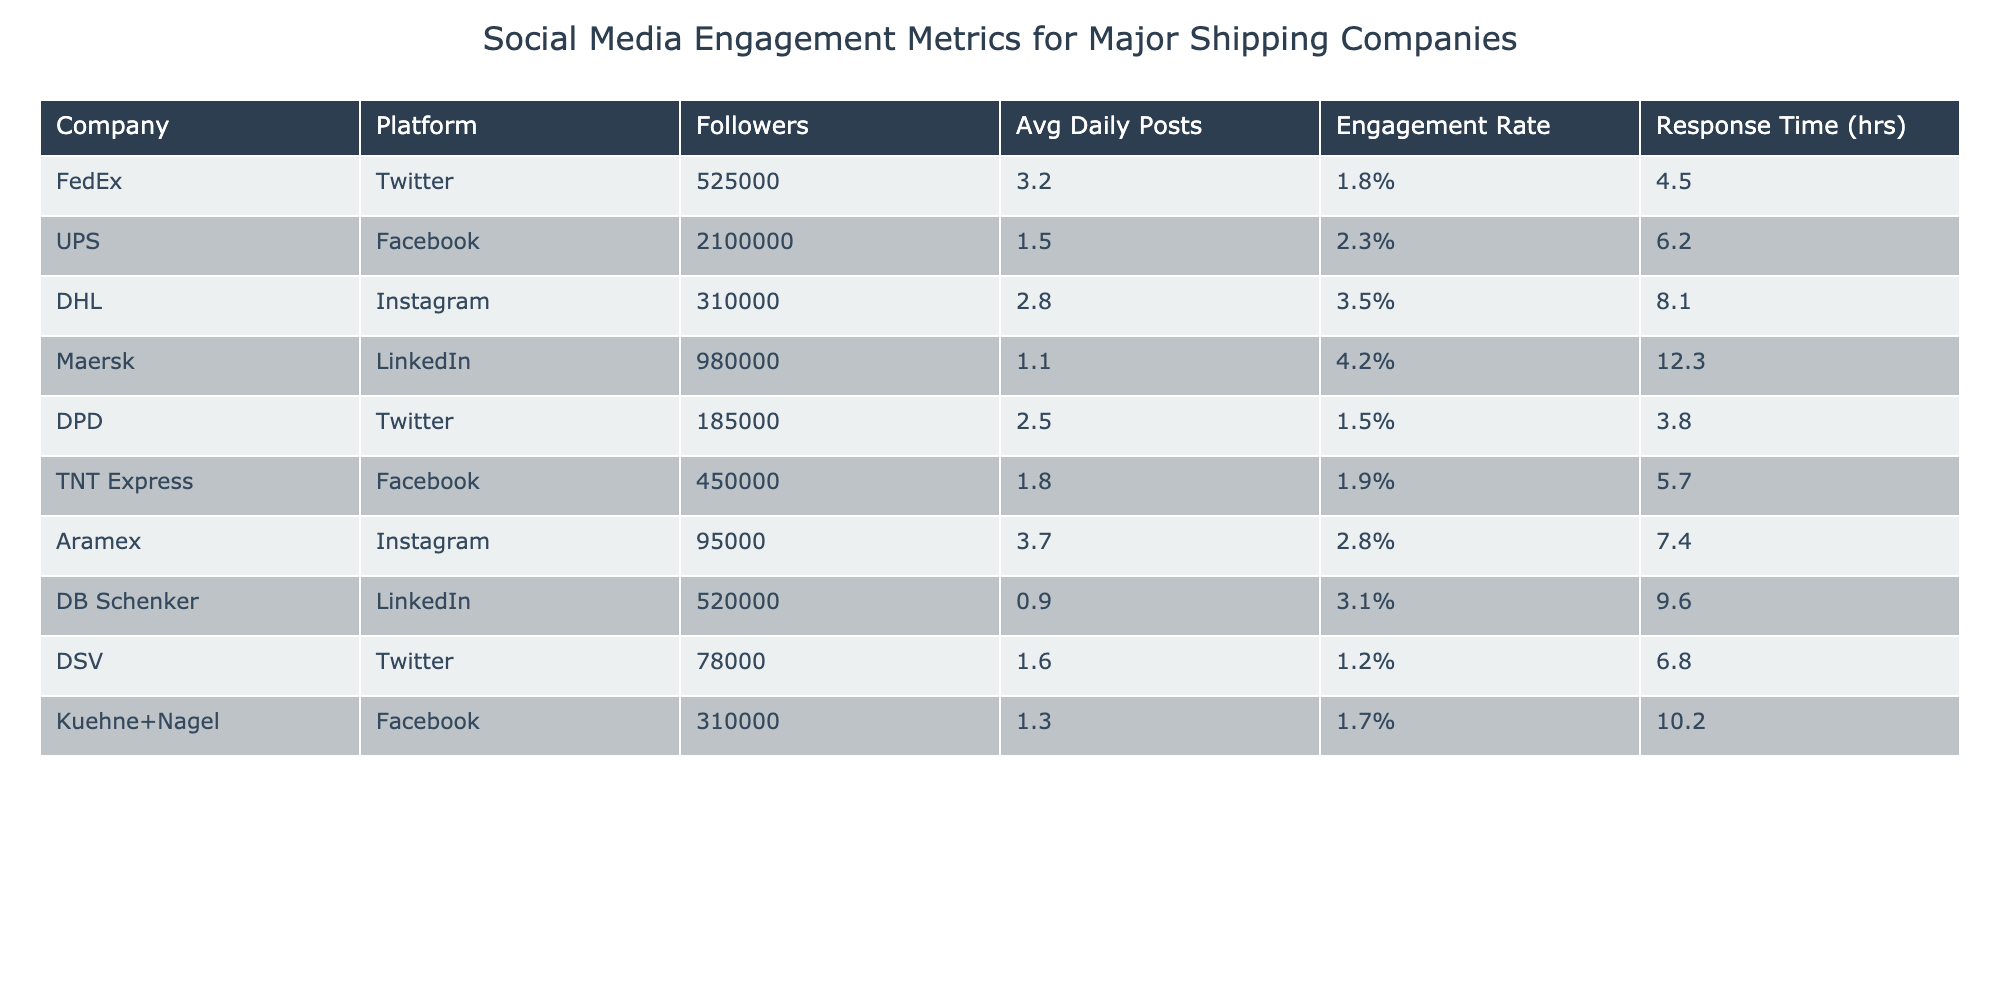What company has the highest number of followers on social media? By reviewing the 'Followers' column, UPS has the highest number of followers with 2,100,000.
Answer: UPS Which social media platform has the highest average daily posts? Looking at the 'Avg Daily Posts' column, Aramex on Instagram has the highest at 3.7 posts per day.
Answer: Aramex on Instagram What is the engagement rate for DHL? The engagement rate for DHL is listed in the 'Engagement Rate' column as 3.5%.
Answer: 3.5% Is the response time for Maersk faster than that of DPD? Maersk has a response time of 12.3 hours and DPD has 3.8 hours; therefore, Maersk's response time is slower than DPD's.
Answer: No What is the average engagement rate for Facebook accounts listed in the table? The engagement rates for Facebook accounts are 2.3% (UPS), 1.9% (TNT Express), and 1.7% (Kuehne+Nagel), totaling 5.9%. There are 3 Facebook accounts, so the average is 5.9% / 3 = 1.9667% (approximately 1.97%).
Answer: 1.97% Which company uses Twitter and has the lowest engagement rate? In the 'Engagement Rate' column, the engagement rates for Twitter accounts are 1.8% (FedEx), 1.5% (DPD), and 1.2% (DSV). DSV has the lowest engagement rate among these at 1.2%.
Answer: DSV If you combine the followers of all companies on Instagram, how many followers would that total? The Instagram accounts listed are DHL (310,000) and Aramex (95,000). Adding these gives 310,000 + 95,000 = 405,000.
Answer: 405,000 Which shipping company has the best engagement rate and what is it? Referring to the 'Engagement Rate' column, Maersk has the best rate at 4.2%.
Answer: Maersk, 4.2% What is the difference between the response times of UPS and TNT Express? UPS has a response time of 6.2 hours and TNT Express has 5.7 hours. The difference is 6.2 - 5.7 = 0.5 hours.
Answer: 0.5 hours How many companies have an engagement rate above 2%? The engagement rates above 2% are UPS (2.3%), DHL (3.5%), Maersk (4.2%), Aramex (2.8%), and DB Schenker (3.1%). That's a total of 5 companies.
Answer: 5 